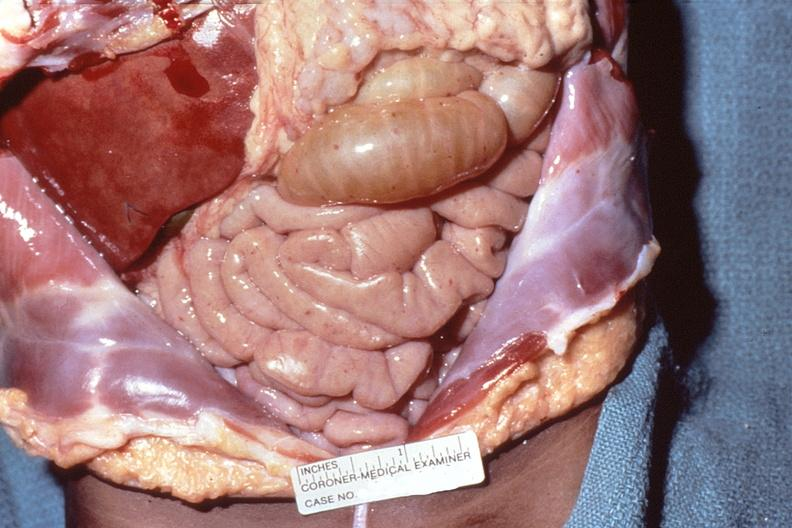s liver with tuberculoid granuloma in glissons present?
Answer the question using a single word or phrase. No 